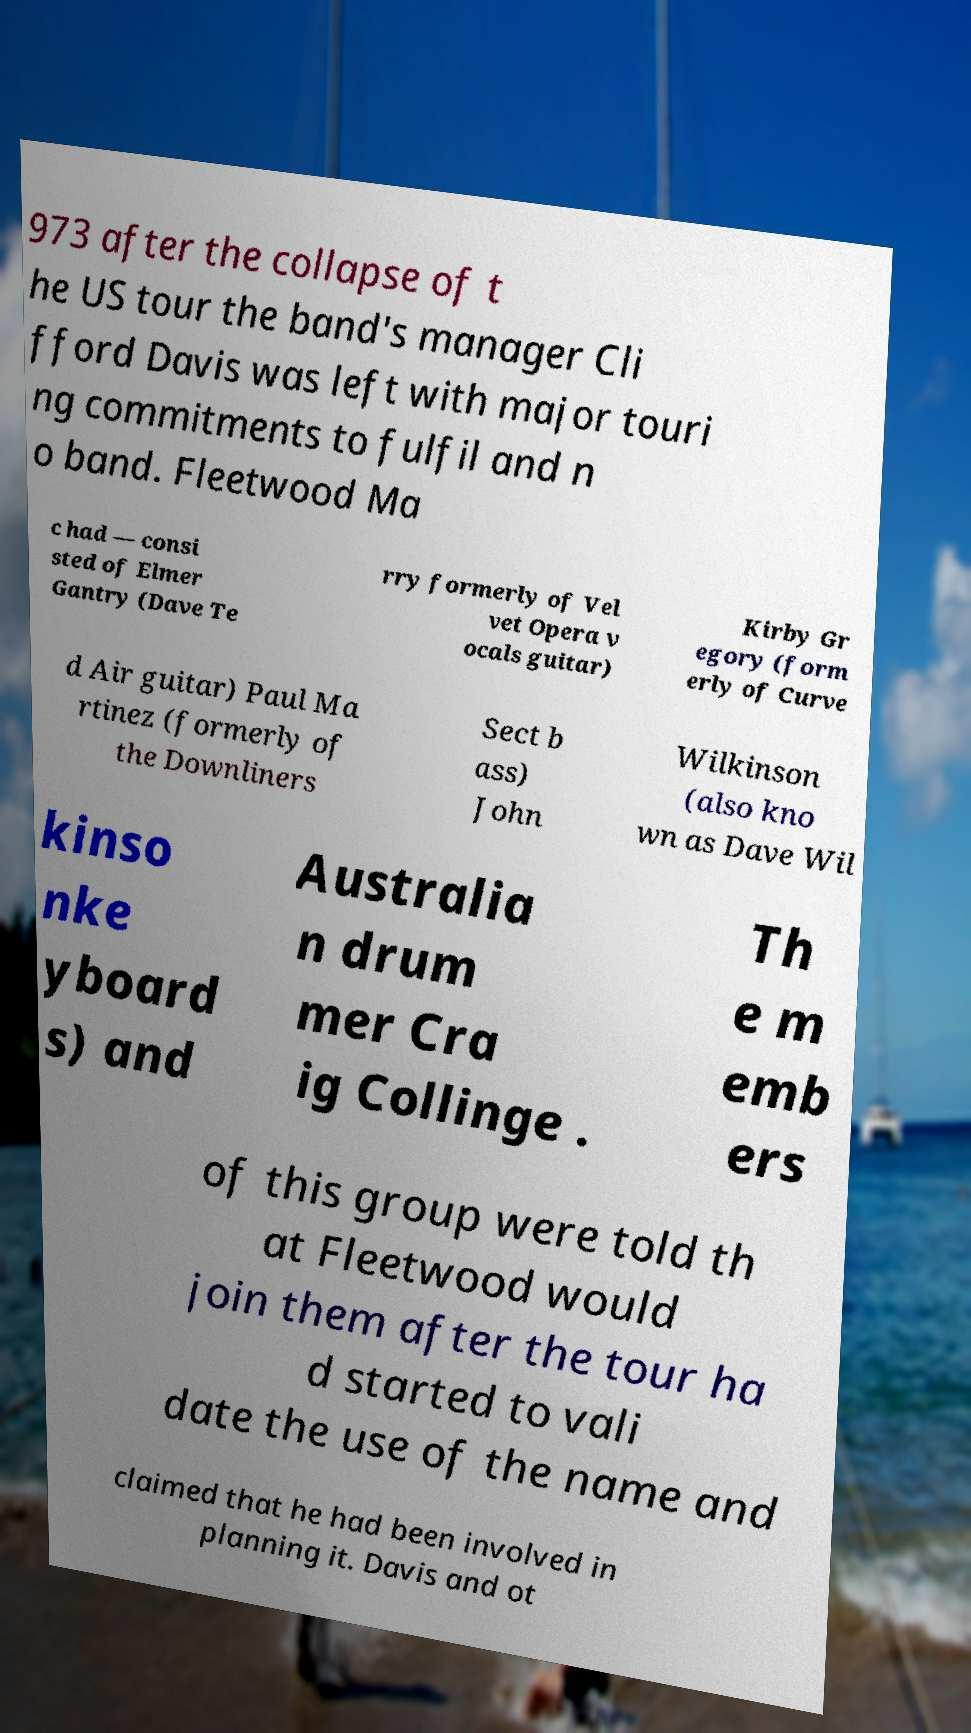Please identify and transcribe the text found in this image. 973 after the collapse of t he US tour the band's manager Cli fford Davis was left with major touri ng commitments to fulfil and n o band. Fleetwood Ma c had — consi sted of Elmer Gantry (Dave Te rry formerly of Vel vet Opera v ocals guitar) Kirby Gr egory (form erly of Curve d Air guitar) Paul Ma rtinez (formerly of the Downliners Sect b ass) John Wilkinson (also kno wn as Dave Wil kinso nke yboard s) and Australia n drum mer Cra ig Collinge . Th e m emb ers of this group were told th at Fleetwood would join them after the tour ha d started to vali date the use of the name and claimed that he had been involved in planning it. Davis and ot 